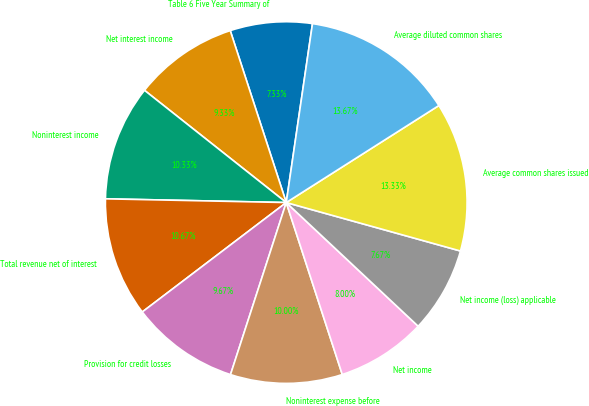<chart> <loc_0><loc_0><loc_500><loc_500><pie_chart><fcel>Table 6 Five Year Summary of<fcel>Net interest income<fcel>Noninterest income<fcel>Total revenue net of interest<fcel>Provision for credit losses<fcel>Noninterest expense before<fcel>Net income<fcel>Net income (loss) applicable<fcel>Average common shares issued<fcel>Average diluted common shares<nl><fcel>7.33%<fcel>9.33%<fcel>10.33%<fcel>10.67%<fcel>9.67%<fcel>10.0%<fcel>8.0%<fcel>7.67%<fcel>13.33%<fcel>13.67%<nl></chart> 